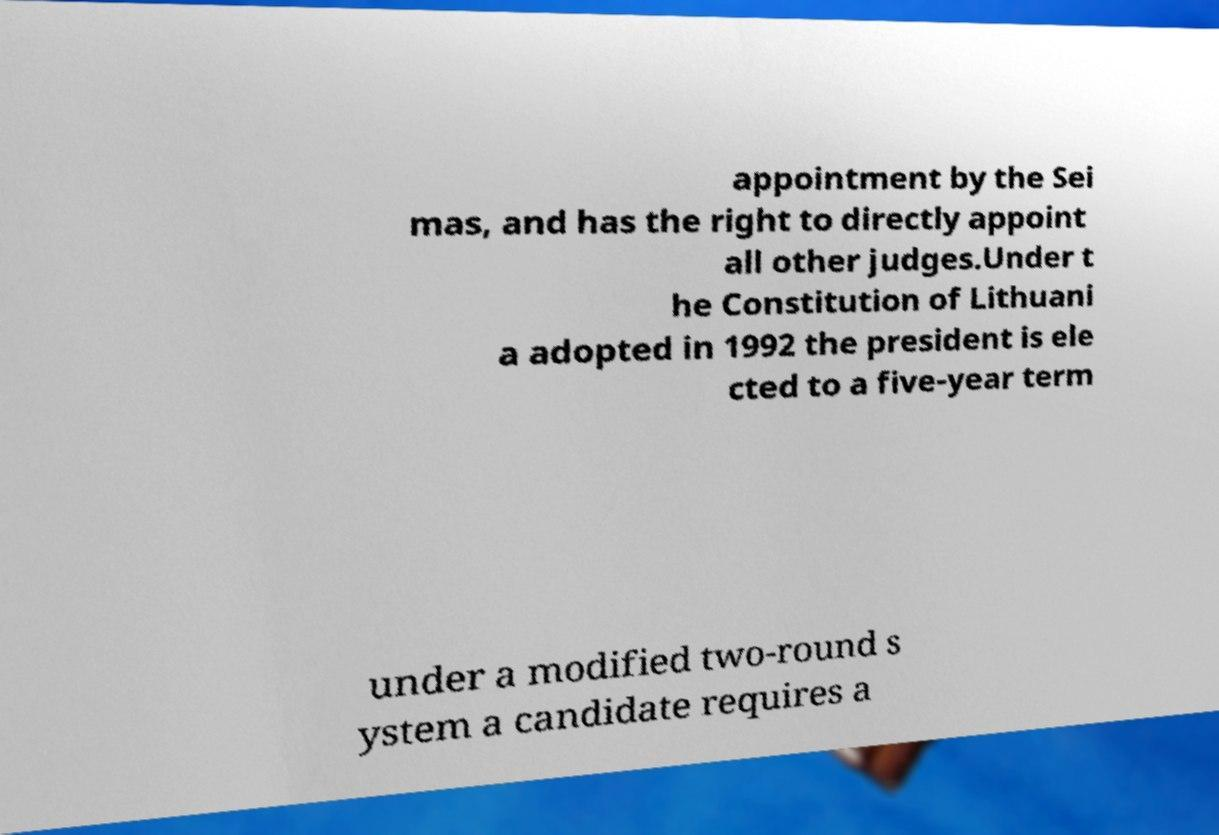Could you extract and type out the text from this image? appointment by the Sei mas, and has the right to directly appoint all other judges.Under t he Constitution of Lithuani a adopted in 1992 the president is ele cted to a five-year term under a modified two-round s ystem a candidate requires a 